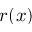<formula> <loc_0><loc_0><loc_500><loc_500>r ( x )</formula> 